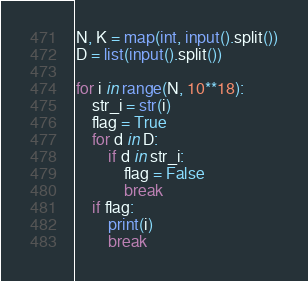Convert code to text. <code><loc_0><loc_0><loc_500><loc_500><_Python_>N, K = map(int, input().split())
D = list(input().split())

for i in range(N, 10**18):
    str_i = str(i)
    flag = True
    for d in D:
        if d in str_i:
            flag = False
            break
    if flag:
        print(i)
        break
</code> 